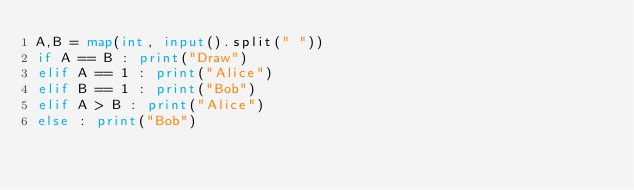<code> <loc_0><loc_0><loc_500><loc_500><_Python_>A,B = map(int, input().split(" "))
if A == B : print("Draw")
elif A == 1 : print("Alice")
elif B == 1 : print("Bob")
elif A > B : print("Alice")
else : print("Bob")
</code> 